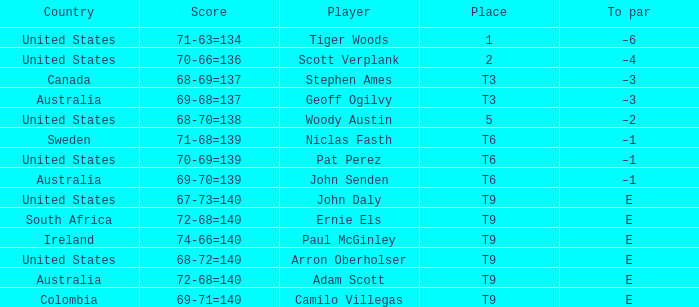What country is Adam Scott from? Australia. 